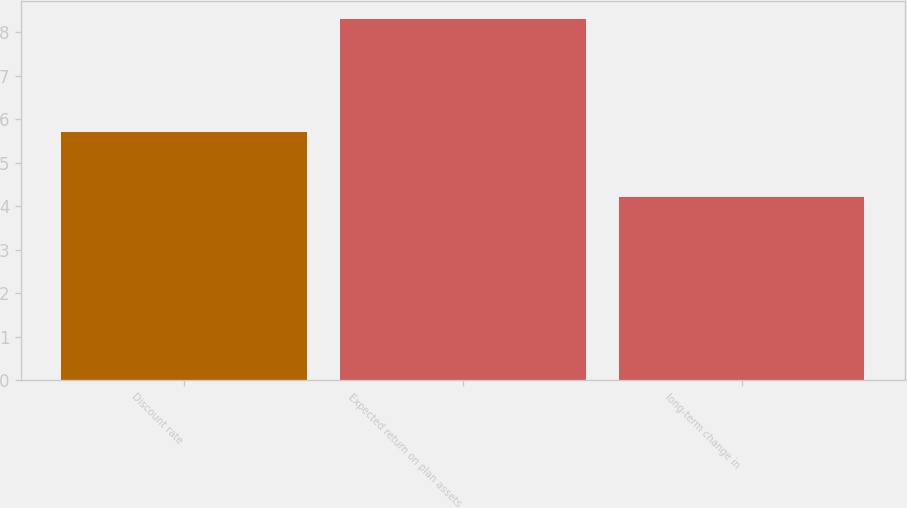Convert chart. <chart><loc_0><loc_0><loc_500><loc_500><bar_chart><fcel>Discount rate<fcel>Expected return on plan assets<fcel>long-term change in<nl><fcel>5.7<fcel>8.3<fcel>4.2<nl></chart> 